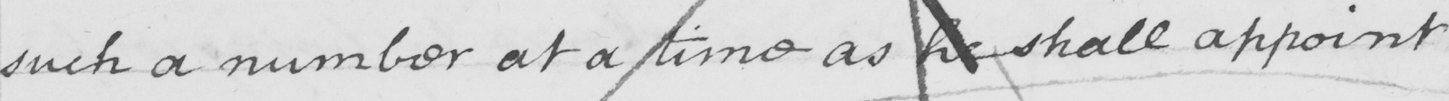What does this handwritten line say? such a number at a time as he shall appoint . 